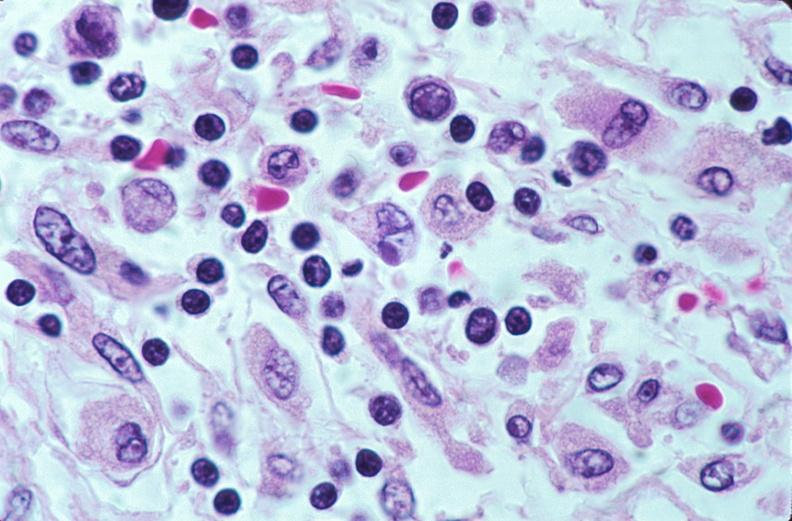what does this image show?
Answer the question using a single word or phrase. Lymph nodes 